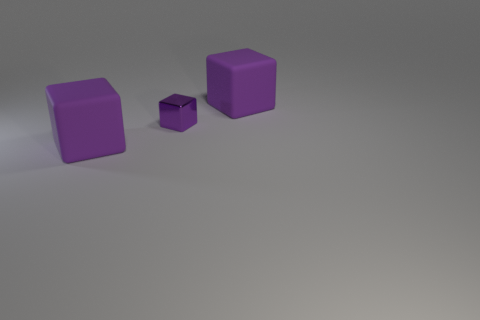Subtract all purple blocks. How many were subtracted if there are2purple blocks left? 1 Subtract all large matte blocks. How many blocks are left? 1 Add 2 purple blocks. How many objects exist? 5 Subtract 0 blue cylinders. How many objects are left? 3 Subtract all tiny purple metallic objects. Subtract all purple metallic objects. How many objects are left? 1 Add 3 tiny purple shiny things. How many tiny purple shiny things are left? 4 Add 3 yellow objects. How many yellow objects exist? 3 